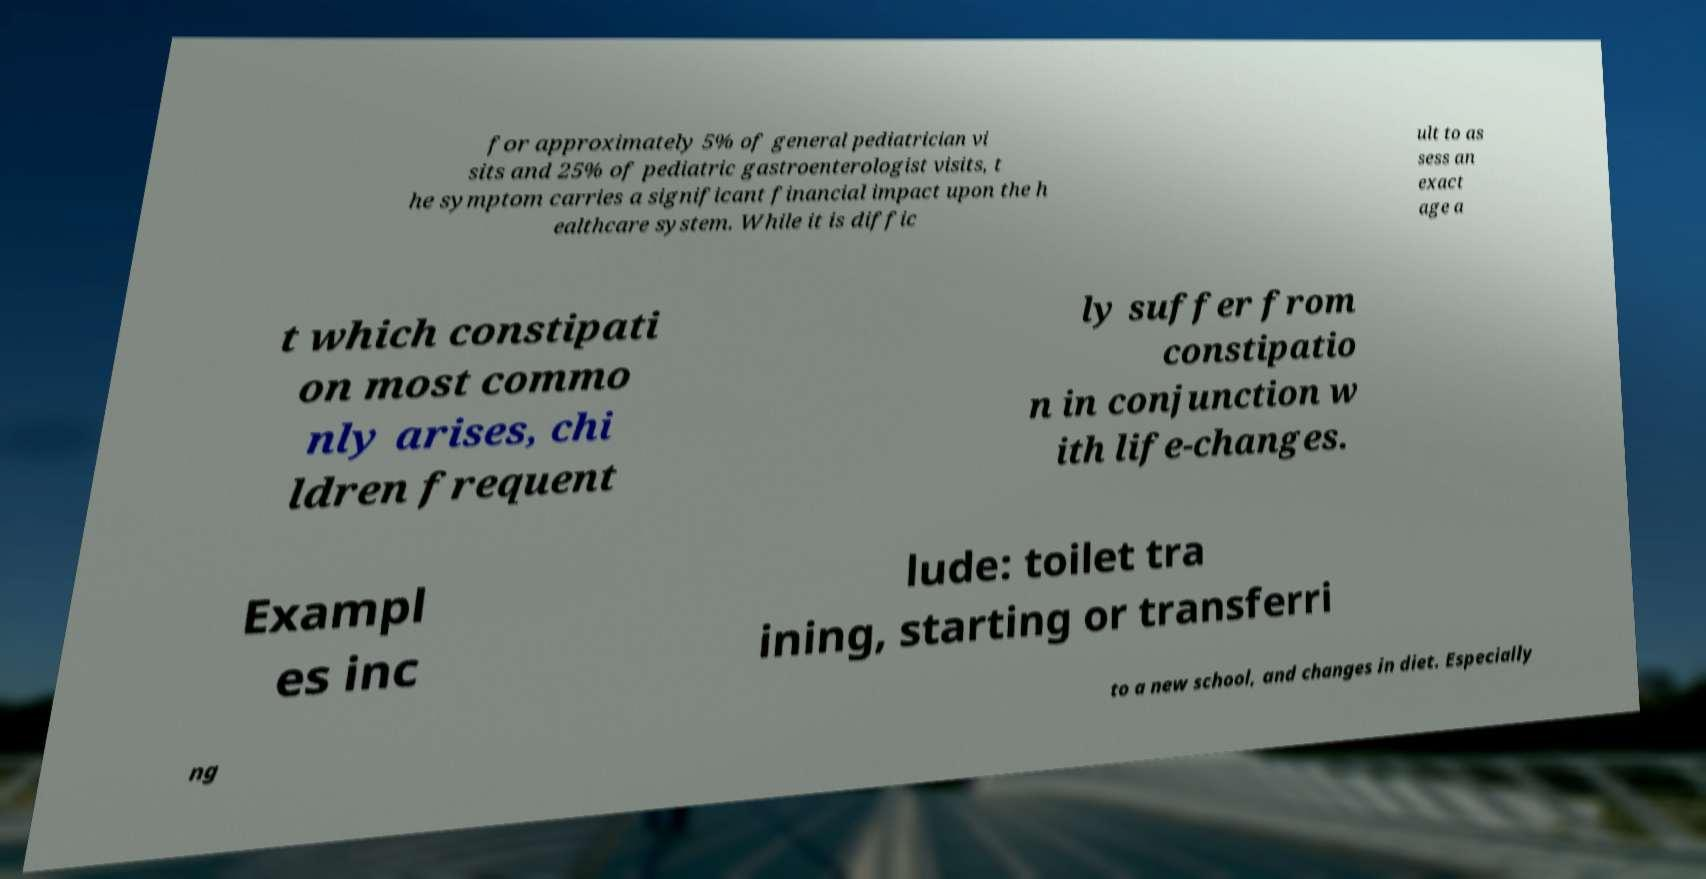Could you assist in decoding the text presented in this image and type it out clearly? for approximately 5% of general pediatrician vi sits and 25% of pediatric gastroenterologist visits, t he symptom carries a significant financial impact upon the h ealthcare system. While it is diffic ult to as sess an exact age a t which constipati on most commo nly arises, chi ldren frequent ly suffer from constipatio n in conjunction w ith life-changes. Exampl es inc lude: toilet tra ining, starting or transferri ng to a new school, and changes in diet. Especially 